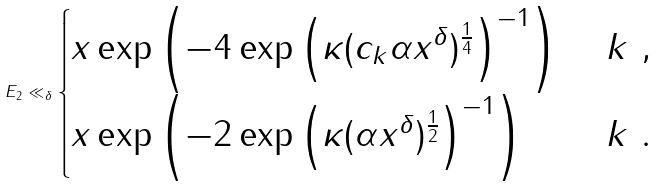Convert formula to latex. <formula><loc_0><loc_0><loc_500><loc_500>E _ { 2 } \ll _ { \delta } \begin{cases} x \exp \left ( - 4 \exp \left ( \kappa ( c _ { k } \alpha x ^ { \delta } ) ^ { \frac { 1 } { 4 } } \right ) ^ { - 1 } \right ) & \ k \ , \\ x \exp \left ( - 2 \exp \left ( \kappa ( \alpha x ^ { \delta } ) ^ { \frac { 1 } { 2 } } \right ) ^ { - 1 } \right ) & \ k \ . \end{cases}</formula> 